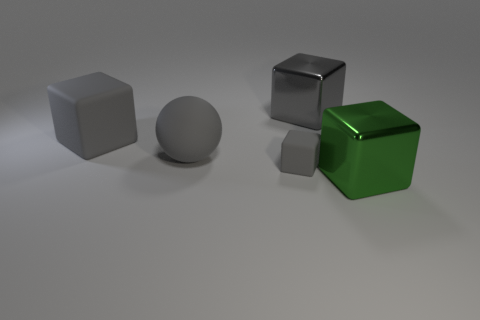Subtract all purple cylinders. How many gray blocks are left? 3 Add 2 tiny gray cubes. How many objects exist? 7 Subtract all cubes. How many objects are left? 1 Subtract 0 brown cylinders. How many objects are left? 5 Subtract all big cyan rubber cylinders. Subtract all large cubes. How many objects are left? 2 Add 5 big rubber balls. How many big rubber balls are left? 6 Add 1 big metallic objects. How many big metallic objects exist? 3 